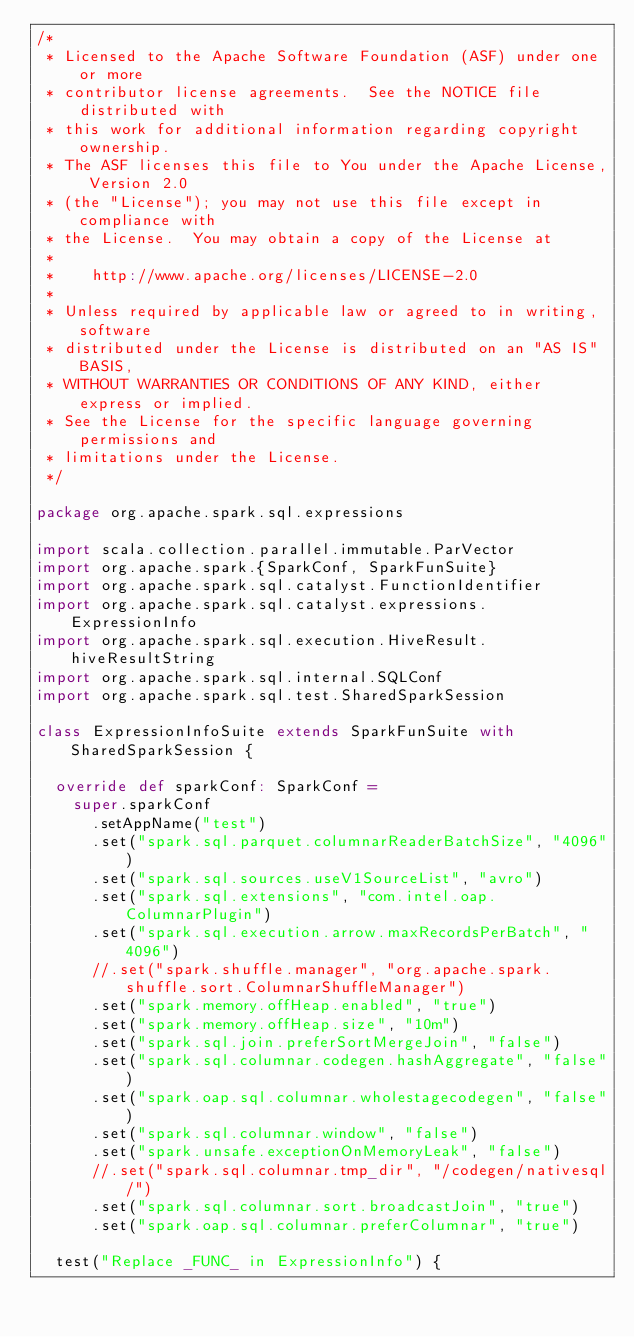<code> <loc_0><loc_0><loc_500><loc_500><_Scala_>/*
 * Licensed to the Apache Software Foundation (ASF) under one or more
 * contributor license agreements.  See the NOTICE file distributed with
 * this work for additional information regarding copyright ownership.
 * The ASF licenses this file to You under the Apache License, Version 2.0
 * (the "License"); you may not use this file except in compliance with
 * the License.  You may obtain a copy of the License at
 *
 *    http://www.apache.org/licenses/LICENSE-2.0
 *
 * Unless required by applicable law or agreed to in writing, software
 * distributed under the License is distributed on an "AS IS" BASIS,
 * WITHOUT WARRANTIES OR CONDITIONS OF ANY KIND, either express or implied.
 * See the License for the specific language governing permissions and
 * limitations under the License.
 */

package org.apache.spark.sql.expressions

import scala.collection.parallel.immutable.ParVector
import org.apache.spark.{SparkConf, SparkFunSuite}
import org.apache.spark.sql.catalyst.FunctionIdentifier
import org.apache.spark.sql.catalyst.expressions.ExpressionInfo
import org.apache.spark.sql.execution.HiveResult.hiveResultString
import org.apache.spark.sql.internal.SQLConf
import org.apache.spark.sql.test.SharedSparkSession

class ExpressionInfoSuite extends SparkFunSuite with SharedSparkSession {

  override def sparkConf: SparkConf =
    super.sparkConf
      .setAppName("test")
      .set("spark.sql.parquet.columnarReaderBatchSize", "4096")
      .set("spark.sql.sources.useV1SourceList", "avro")
      .set("spark.sql.extensions", "com.intel.oap.ColumnarPlugin")
      .set("spark.sql.execution.arrow.maxRecordsPerBatch", "4096")
      //.set("spark.shuffle.manager", "org.apache.spark.shuffle.sort.ColumnarShuffleManager")
      .set("spark.memory.offHeap.enabled", "true")
      .set("spark.memory.offHeap.size", "10m")
      .set("spark.sql.join.preferSortMergeJoin", "false")
      .set("spark.sql.columnar.codegen.hashAggregate", "false")
      .set("spark.oap.sql.columnar.wholestagecodegen", "false")
      .set("spark.sql.columnar.window", "false")
      .set("spark.unsafe.exceptionOnMemoryLeak", "false")
      //.set("spark.sql.columnar.tmp_dir", "/codegen/nativesql/")
      .set("spark.sql.columnar.sort.broadcastJoin", "true")
      .set("spark.oap.sql.columnar.preferColumnar", "true")

  test("Replace _FUNC_ in ExpressionInfo") {</code> 